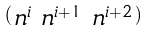<formula> <loc_0><loc_0><loc_500><loc_500>\begin{psmallmatrix} n ^ { i } & n ^ { i + 1 } & n ^ { i + 2 } \end{psmallmatrix}</formula> 